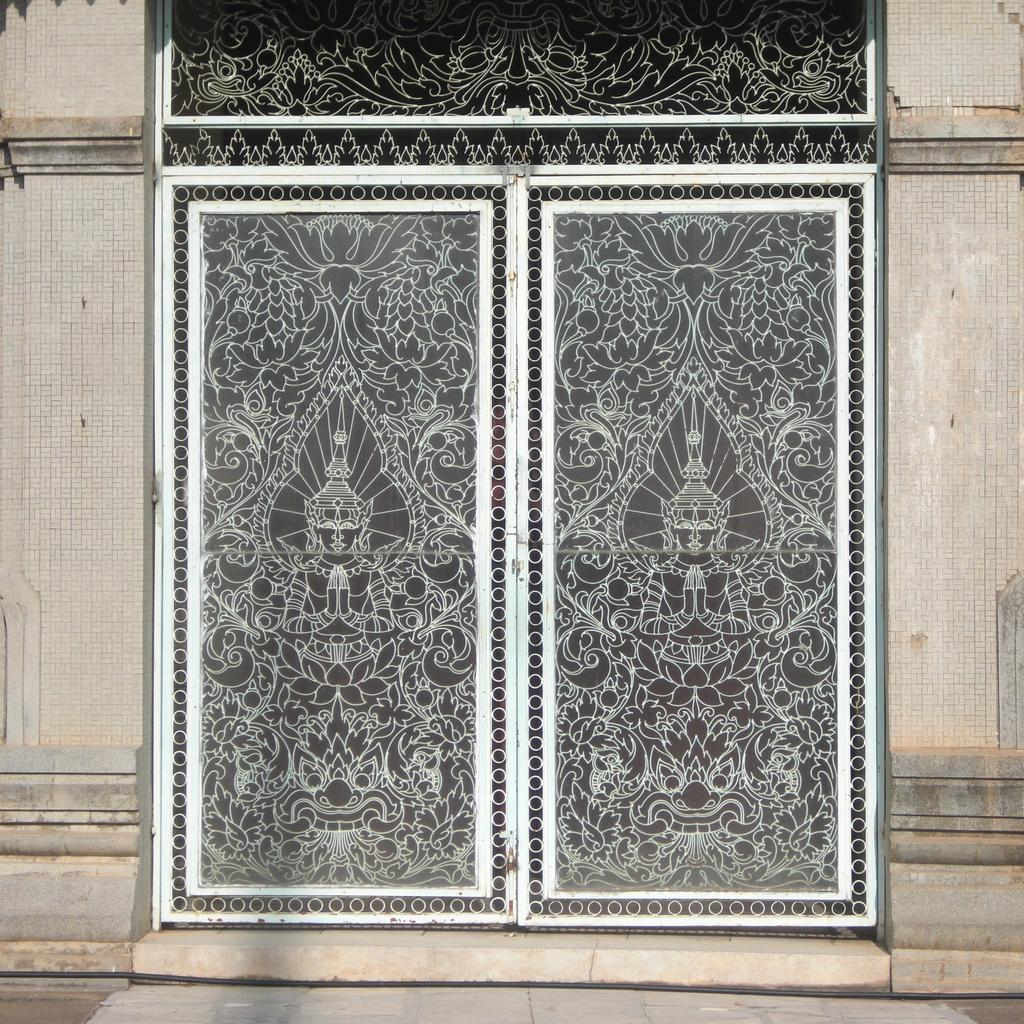What can be seen on both sides of the image? There are walls on both sides of the image. What is located in the center of the image? There is a gate in the center of the image. Can you describe the gate in the image? The gate has some design on it. What type of tooth is visible on the gate in the image? There is no tooth present on the gate in the image. What kind of sticks are used to create the design on the gate? The image does not provide information about the materials used to create the design on the gate. 